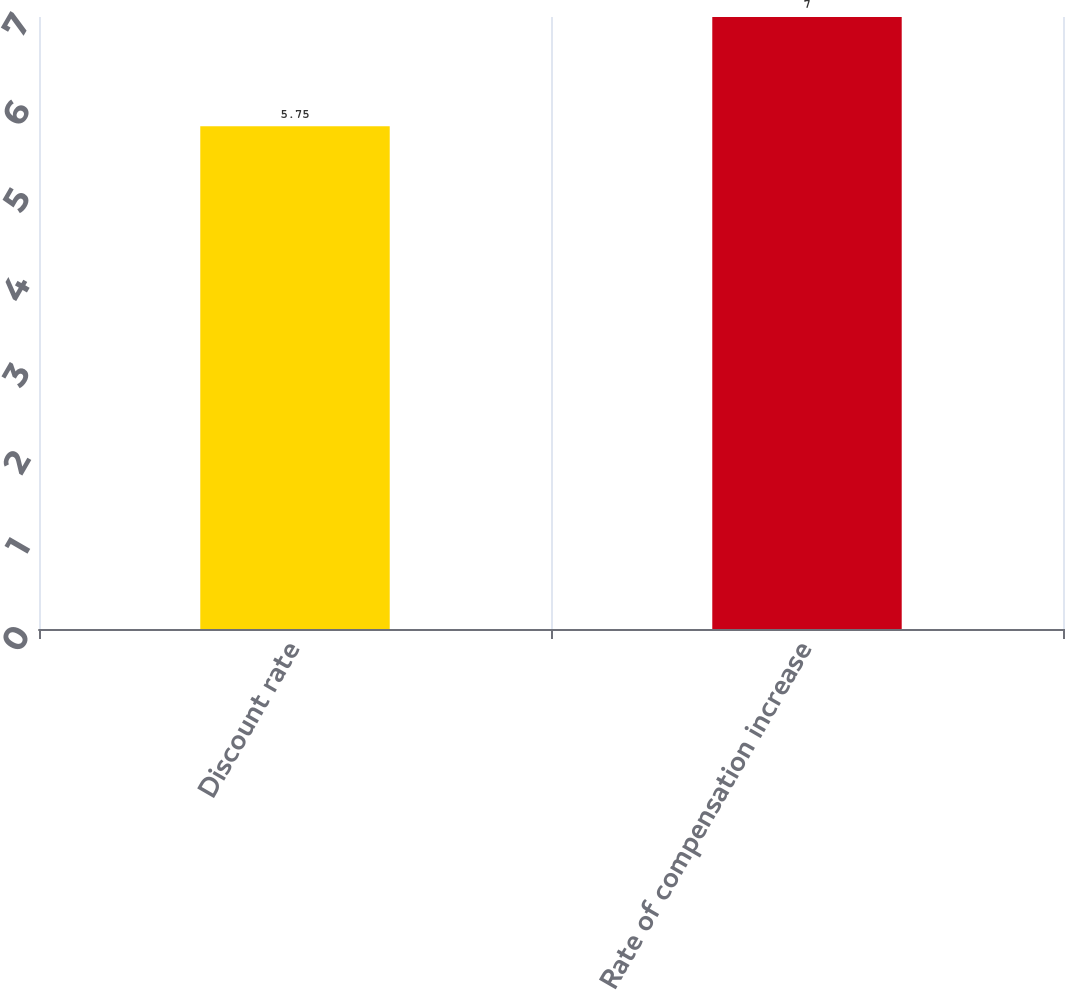Convert chart. <chart><loc_0><loc_0><loc_500><loc_500><bar_chart><fcel>Discount rate<fcel>Rate of compensation increase<nl><fcel>5.75<fcel>7<nl></chart> 